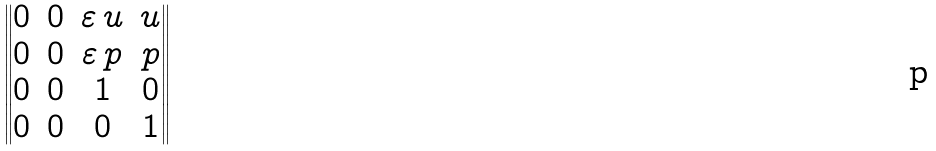Convert formula to latex. <formula><loc_0><loc_0><loc_500><loc_500>\begin{Vmatrix} 0 & 0 & \varepsilon \, u & u \\ 0 & 0 & \varepsilon \, p & p \\ 0 & 0 & 1 & 0 \\ 0 & 0 & 0 & 1 \end{Vmatrix}</formula> 